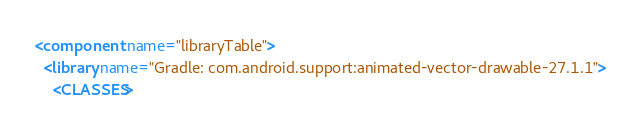<code> <loc_0><loc_0><loc_500><loc_500><_XML_><component name="libraryTable">
  <library name="Gradle: com.android.support:animated-vector-drawable-27.1.1">
    <CLASSES></code> 